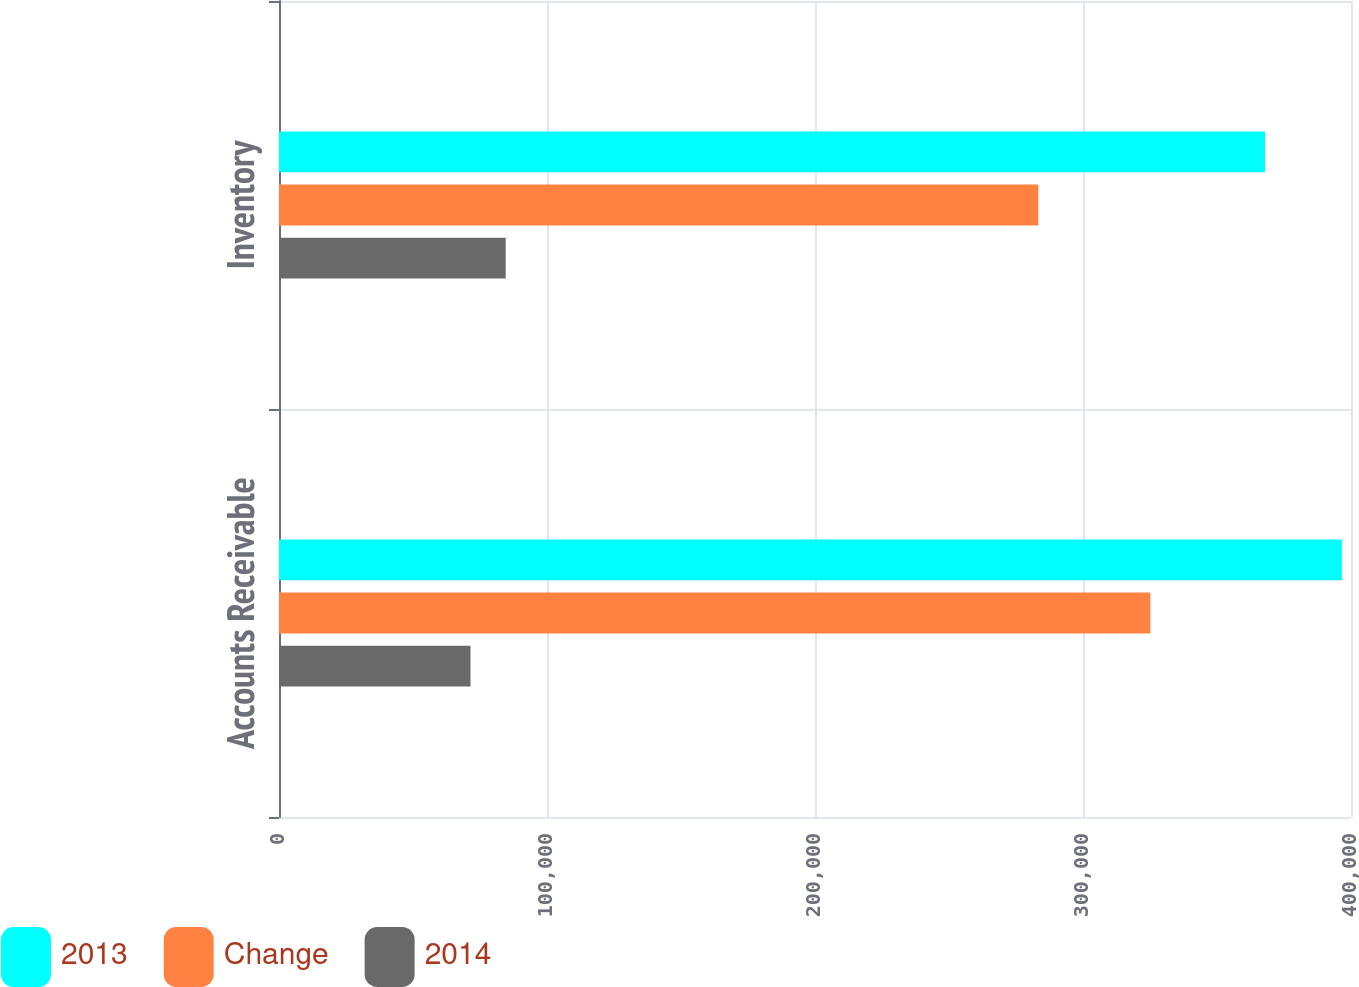<chart> <loc_0><loc_0><loc_500><loc_500><stacked_bar_chart><ecel><fcel>Accounts Receivable<fcel>Inventory<nl><fcel>2013<fcel>396605<fcel>367927<nl><fcel>Change<fcel>325144<fcel>283337<nl><fcel>2014<fcel>71461<fcel>84590<nl></chart> 